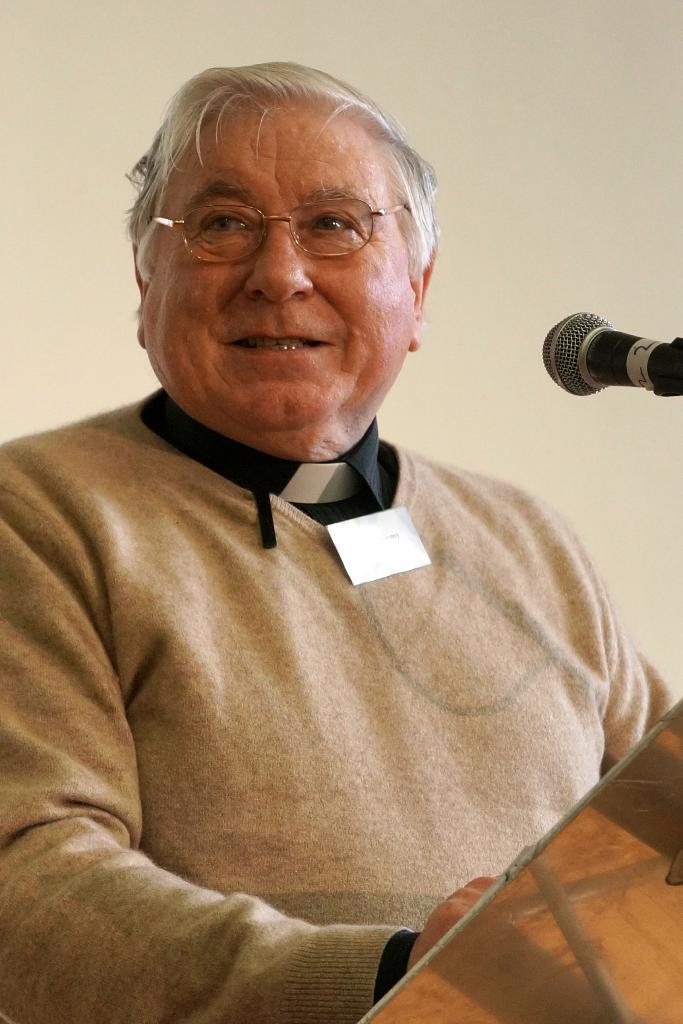Who is present in the image? There is a man in the image. What is the man wearing? The man is wearing spectacles. What object is in front of the man? There is a mic in front of the man. What can be seen behind the man? There is a wall in the background of the image. What flavor of ice cream is the man holding in the image? There is no ice cream present in the image, and therefore no flavor can be determined. 